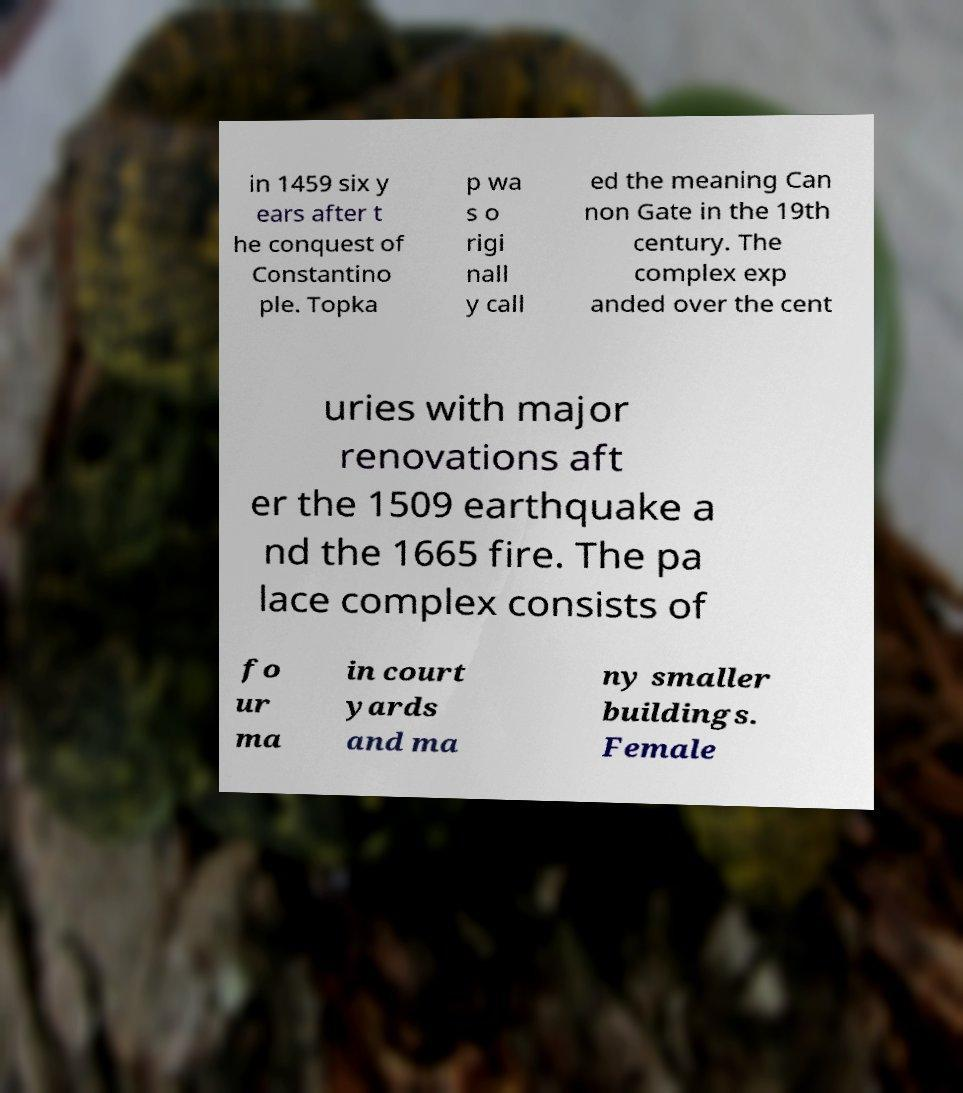Can you read and provide the text displayed in the image?This photo seems to have some interesting text. Can you extract and type it out for me? in 1459 six y ears after t he conquest of Constantino ple. Topka p wa s o rigi nall y call ed the meaning Can non Gate in the 19th century. The complex exp anded over the cent uries with major renovations aft er the 1509 earthquake a nd the 1665 fire. The pa lace complex consists of fo ur ma in court yards and ma ny smaller buildings. Female 